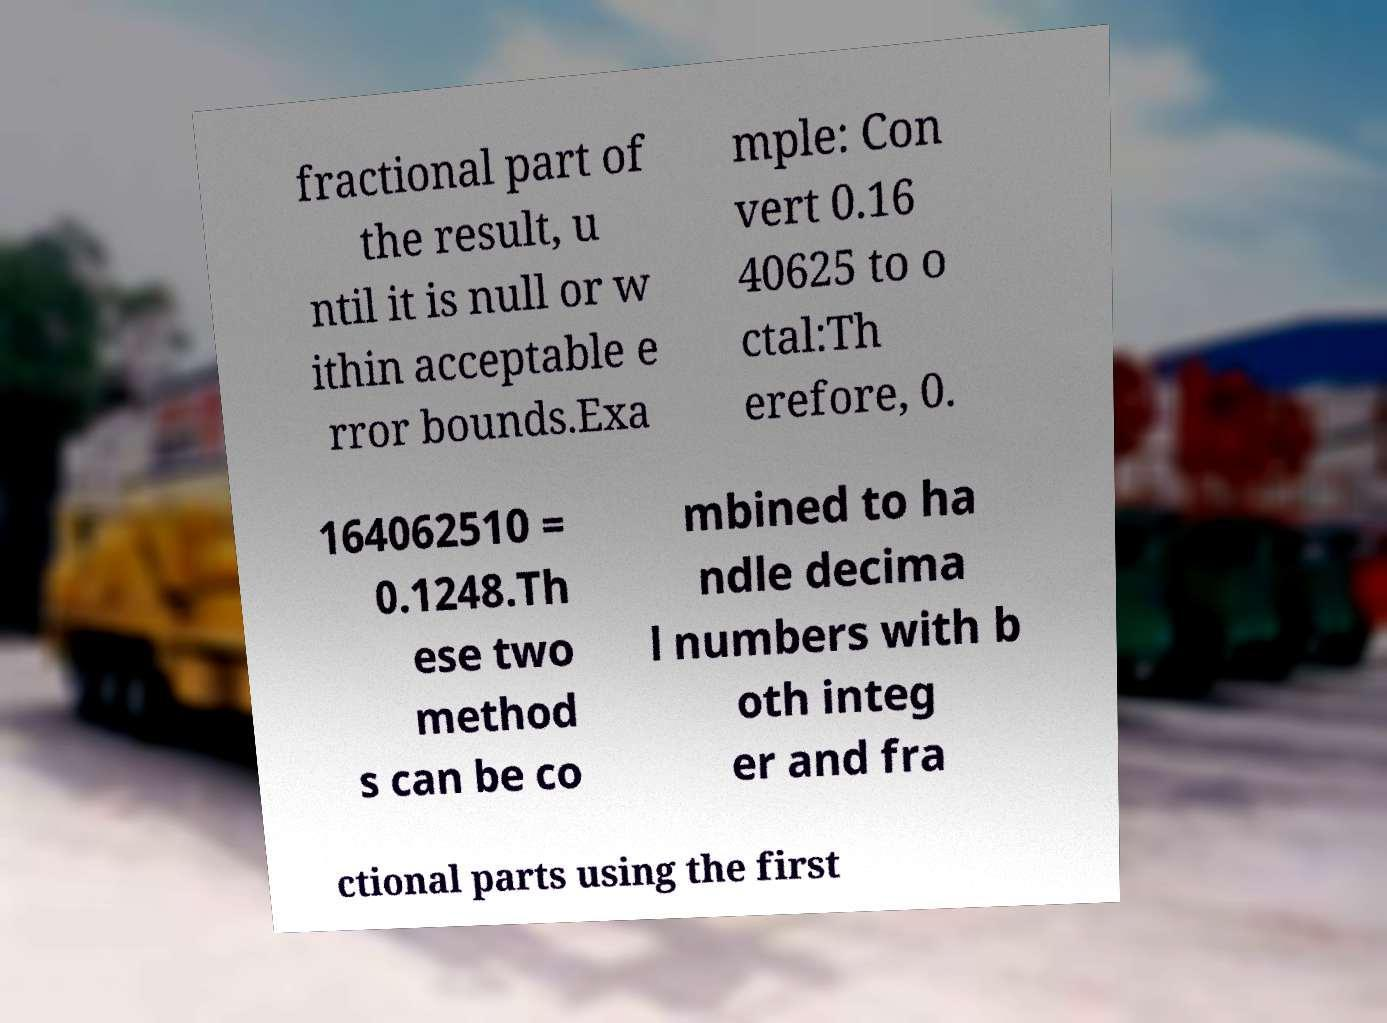Can you accurately transcribe the text from the provided image for me? fractional part of the result, u ntil it is null or w ithin acceptable e rror bounds.Exa mple: Con vert 0.16 40625 to o ctal:Th erefore, 0. 164062510 = 0.1248.Th ese two method s can be co mbined to ha ndle decima l numbers with b oth integ er and fra ctional parts using the first 